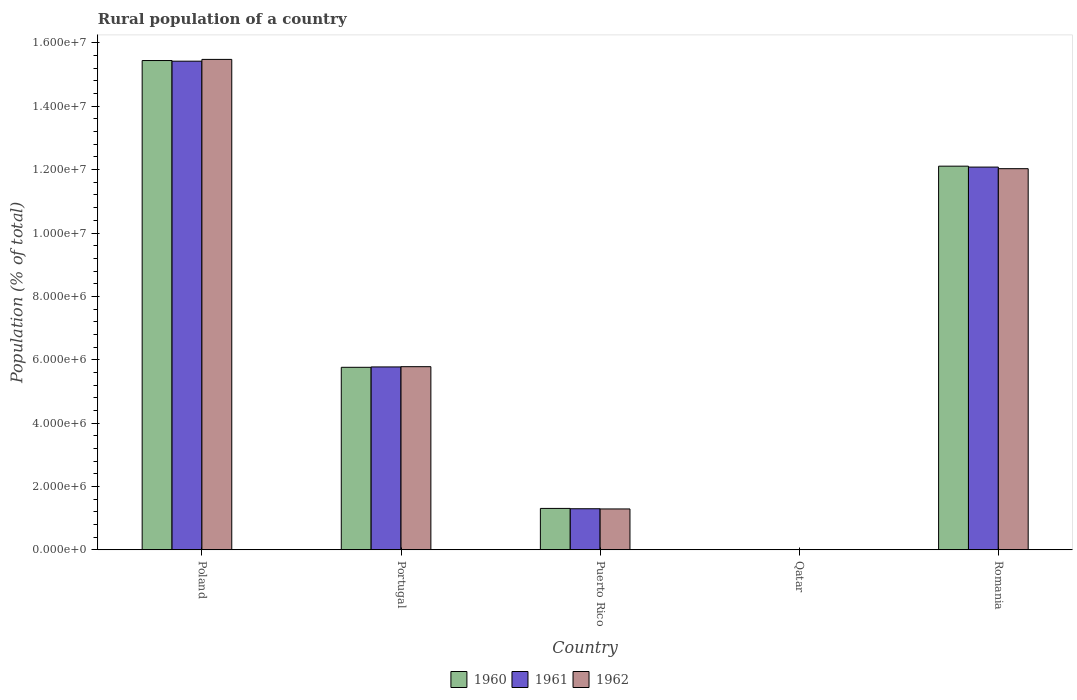How many different coloured bars are there?
Your answer should be very brief. 3. How many groups of bars are there?
Give a very brief answer. 5. Are the number of bars on each tick of the X-axis equal?
Provide a short and direct response. Yes. How many bars are there on the 1st tick from the left?
Ensure brevity in your answer.  3. What is the rural population in 1962 in Portugal?
Your answer should be compact. 5.78e+06. Across all countries, what is the maximum rural population in 1960?
Your answer should be very brief. 1.54e+07. Across all countries, what is the minimum rural population in 1961?
Offer a very short reply. 7347. In which country was the rural population in 1961 maximum?
Offer a very short reply. Poland. In which country was the rural population in 1961 minimum?
Keep it short and to the point. Qatar. What is the total rural population in 1961 in the graph?
Make the answer very short. 3.46e+07. What is the difference between the rural population in 1961 in Poland and that in Portugal?
Offer a very short reply. 9.65e+06. What is the difference between the rural population in 1961 in Qatar and the rural population in 1962 in Puerto Rico?
Offer a very short reply. -1.28e+06. What is the average rural population in 1960 per country?
Provide a succinct answer. 6.93e+06. What is the difference between the rural population of/in 1962 and rural population of/in 1960 in Puerto Rico?
Your response must be concise. -1.69e+04. In how many countries, is the rural population in 1962 greater than 13600000 %?
Offer a very short reply. 1. What is the ratio of the rural population in 1961 in Poland to that in Portugal?
Give a very brief answer. 2.67. What is the difference between the highest and the second highest rural population in 1961?
Offer a very short reply. 9.65e+06. What is the difference between the highest and the lowest rural population in 1961?
Offer a terse response. 1.54e+07. Is the sum of the rural population in 1962 in Portugal and Romania greater than the maximum rural population in 1960 across all countries?
Your response must be concise. Yes. Is it the case that in every country, the sum of the rural population in 1962 and rural population in 1960 is greater than the rural population in 1961?
Ensure brevity in your answer.  Yes. Are all the bars in the graph horizontal?
Provide a succinct answer. No. What is the difference between two consecutive major ticks on the Y-axis?
Offer a very short reply. 2.00e+06. Are the values on the major ticks of Y-axis written in scientific E-notation?
Provide a succinct answer. Yes. Does the graph contain grids?
Provide a short and direct response. No. How many legend labels are there?
Keep it short and to the point. 3. What is the title of the graph?
Your answer should be very brief. Rural population of a country. Does "1960" appear as one of the legend labels in the graph?
Your answer should be very brief. Yes. What is the label or title of the Y-axis?
Offer a terse response. Population (% of total). What is the Population (% of total) in 1960 in Poland?
Your response must be concise. 1.54e+07. What is the Population (% of total) of 1961 in Poland?
Keep it short and to the point. 1.54e+07. What is the Population (% of total) in 1962 in Poland?
Ensure brevity in your answer.  1.55e+07. What is the Population (% of total) of 1960 in Portugal?
Your response must be concise. 5.76e+06. What is the Population (% of total) in 1961 in Portugal?
Provide a succinct answer. 5.77e+06. What is the Population (% of total) in 1962 in Portugal?
Ensure brevity in your answer.  5.78e+06. What is the Population (% of total) in 1960 in Puerto Rico?
Your answer should be very brief. 1.31e+06. What is the Population (% of total) in 1961 in Puerto Rico?
Offer a terse response. 1.30e+06. What is the Population (% of total) in 1962 in Puerto Rico?
Make the answer very short. 1.29e+06. What is the Population (% of total) of 1960 in Qatar?
Give a very brief answer. 6966. What is the Population (% of total) in 1961 in Qatar?
Your answer should be compact. 7347. What is the Population (% of total) in 1962 in Qatar?
Your response must be concise. 7809. What is the Population (% of total) of 1960 in Romania?
Your response must be concise. 1.21e+07. What is the Population (% of total) in 1961 in Romania?
Offer a very short reply. 1.21e+07. What is the Population (% of total) of 1962 in Romania?
Offer a terse response. 1.20e+07. Across all countries, what is the maximum Population (% of total) of 1960?
Offer a terse response. 1.54e+07. Across all countries, what is the maximum Population (% of total) in 1961?
Your response must be concise. 1.54e+07. Across all countries, what is the maximum Population (% of total) in 1962?
Your answer should be compact. 1.55e+07. Across all countries, what is the minimum Population (% of total) of 1960?
Provide a short and direct response. 6966. Across all countries, what is the minimum Population (% of total) in 1961?
Offer a very short reply. 7347. Across all countries, what is the minimum Population (% of total) in 1962?
Offer a very short reply. 7809. What is the total Population (% of total) of 1960 in the graph?
Your answer should be very brief. 3.46e+07. What is the total Population (% of total) of 1961 in the graph?
Give a very brief answer. 3.46e+07. What is the total Population (% of total) of 1962 in the graph?
Give a very brief answer. 3.46e+07. What is the difference between the Population (% of total) of 1960 in Poland and that in Portugal?
Make the answer very short. 9.68e+06. What is the difference between the Population (% of total) of 1961 in Poland and that in Portugal?
Ensure brevity in your answer.  9.65e+06. What is the difference between the Population (% of total) in 1962 in Poland and that in Portugal?
Your answer should be compact. 9.70e+06. What is the difference between the Population (% of total) of 1960 in Poland and that in Puerto Rico?
Offer a very short reply. 1.41e+07. What is the difference between the Population (% of total) of 1961 in Poland and that in Puerto Rico?
Offer a very short reply. 1.41e+07. What is the difference between the Population (% of total) in 1962 in Poland and that in Puerto Rico?
Keep it short and to the point. 1.42e+07. What is the difference between the Population (% of total) of 1960 in Poland and that in Qatar?
Provide a short and direct response. 1.54e+07. What is the difference between the Population (% of total) of 1961 in Poland and that in Qatar?
Your answer should be compact. 1.54e+07. What is the difference between the Population (% of total) in 1962 in Poland and that in Qatar?
Give a very brief answer. 1.55e+07. What is the difference between the Population (% of total) in 1960 in Poland and that in Romania?
Ensure brevity in your answer.  3.33e+06. What is the difference between the Population (% of total) of 1961 in Poland and that in Romania?
Keep it short and to the point. 3.34e+06. What is the difference between the Population (% of total) of 1962 in Poland and that in Romania?
Your answer should be compact. 3.45e+06. What is the difference between the Population (% of total) in 1960 in Portugal and that in Puerto Rico?
Your response must be concise. 4.45e+06. What is the difference between the Population (% of total) of 1961 in Portugal and that in Puerto Rico?
Offer a terse response. 4.48e+06. What is the difference between the Population (% of total) of 1962 in Portugal and that in Puerto Rico?
Provide a short and direct response. 4.49e+06. What is the difference between the Population (% of total) in 1960 in Portugal and that in Qatar?
Your answer should be compact. 5.75e+06. What is the difference between the Population (% of total) of 1961 in Portugal and that in Qatar?
Offer a very short reply. 5.77e+06. What is the difference between the Population (% of total) of 1962 in Portugal and that in Qatar?
Ensure brevity in your answer.  5.77e+06. What is the difference between the Population (% of total) in 1960 in Portugal and that in Romania?
Ensure brevity in your answer.  -6.35e+06. What is the difference between the Population (% of total) in 1961 in Portugal and that in Romania?
Keep it short and to the point. -6.31e+06. What is the difference between the Population (% of total) in 1962 in Portugal and that in Romania?
Your answer should be compact. -6.25e+06. What is the difference between the Population (% of total) of 1960 in Puerto Rico and that in Qatar?
Your response must be concise. 1.30e+06. What is the difference between the Population (% of total) of 1961 in Puerto Rico and that in Qatar?
Your answer should be very brief. 1.29e+06. What is the difference between the Population (% of total) in 1962 in Puerto Rico and that in Qatar?
Make the answer very short. 1.28e+06. What is the difference between the Population (% of total) in 1960 in Puerto Rico and that in Romania?
Your answer should be compact. -1.08e+07. What is the difference between the Population (% of total) in 1961 in Puerto Rico and that in Romania?
Keep it short and to the point. -1.08e+07. What is the difference between the Population (% of total) of 1962 in Puerto Rico and that in Romania?
Offer a terse response. -1.07e+07. What is the difference between the Population (% of total) in 1960 in Qatar and that in Romania?
Your answer should be compact. -1.21e+07. What is the difference between the Population (% of total) of 1961 in Qatar and that in Romania?
Your answer should be compact. -1.21e+07. What is the difference between the Population (% of total) of 1962 in Qatar and that in Romania?
Offer a terse response. -1.20e+07. What is the difference between the Population (% of total) in 1960 in Poland and the Population (% of total) in 1961 in Portugal?
Keep it short and to the point. 9.67e+06. What is the difference between the Population (% of total) of 1960 in Poland and the Population (% of total) of 1962 in Portugal?
Your answer should be compact. 9.66e+06. What is the difference between the Population (% of total) of 1961 in Poland and the Population (% of total) of 1962 in Portugal?
Give a very brief answer. 9.64e+06. What is the difference between the Population (% of total) in 1960 in Poland and the Population (% of total) in 1961 in Puerto Rico?
Keep it short and to the point. 1.41e+07. What is the difference between the Population (% of total) of 1960 in Poland and the Population (% of total) of 1962 in Puerto Rico?
Give a very brief answer. 1.42e+07. What is the difference between the Population (% of total) in 1961 in Poland and the Population (% of total) in 1962 in Puerto Rico?
Your answer should be very brief. 1.41e+07. What is the difference between the Population (% of total) in 1960 in Poland and the Population (% of total) in 1961 in Qatar?
Make the answer very short. 1.54e+07. What is the difference between the Population (% of total) in 1960 in Poland and the Population (% of total) in 1962 in Qatar?
Your response must be concise. 1.54e+07. What is the difference between the Population (% of total) in 1961 in Poland and the Population (% of total) in 1962 in Qatar?
Your response must be concise. 1.54e+07. What is the difference between the Population (% of total) of 1960 in Poland and the Population (% of total) of 1961 in Romania?
Your answer should be very brief. 3.36e+06. What is the difference between the Population (% of total) of 1960 in Poland and the Population (% of total) of 1962 in Romania?
Keep it short and to the point. 3.41e+06. What is the difference between the Population (% of total) of 1961 in Poland and the Population (% of total) of 1962 in Romania?
Make the answer very short. 3.39e+06. What is the difference between the Population (% of total) of 1960 in Portugal and the Population (% of total) of 1961 in Puerto Rico?
Keep it short and to the point. 4.46e+06. What is the difference between the Population (% of total) in 1960 in Portugal and the Population (% of total) in 1962 in Puerto Rico?
Provide a succinct answer. 4.47e+06. What is the difference between the Population (% of total) of 1961 in Portugal and the Population (% of total) of 1962 in Puerto Rico?
Provide a short and direct response. 4.48e+06. What is the difference between the Population (% of total) of 1960 in Portugal and the Population (% of total) of 1961 in Qatar?
Give a very brief answer. 5.75e+06. What is the difference between the Population (% of total) in 1960 in Portugal and the Population (% of total) in 1962 in Qatar?
Your answer should be compact. 5.75e+06. What is the difference between the Population (% of total) of 1961 in Portugal and the Population (% of total) of 1962 in Qatar?
Your answer should be compact. 5.77e+06. What is the difference between the Population (% of total) in 1960 in Portugal and the Population (% of total) in 1961 in Romania?
Your answer should be very brief. -6.32e+06. What is the difference between the Population (% of total) of 1960 in Portugal and the Population (% of total) of 1962 in Romania?
Your response must be concise. -6.27e+06. What is the difference between the Population (% of total) in 1961 in Portugal and the Population (% of total) in 1962 in Romania?
Your response must be concise. -6.26e+06. What is the difference between the Population (% of total) of 1960 in Puerto Rico and the Population (% of total) of 1961 in Qatar?
Ensure brevity in your answer.  1.30e+06. What is the difference between the Population (% of total) in 1960 in Puerto Rico and the Population (% of total) in 1962 in Qatar?
Keep it short and to the point. 1.30e+06. What is the difference between the Population (% of total) in 1961 in Puerto Rico and the Population (% of total) in 1962 in Qatar?
Your response must be concise. 1.29e+06. What is the difference between the Population (% of total) of 1960 in Puerto Rico and the Population (% of total) of 1961 in Romania?
Provide a short and direct response. -1.08e+07. What is the difference between the Population (% of total) of 1960 in Puerto Rico and the Population (% of total) of 1962 in Romania?
Provide a succinct answer. -1.07e+07. What is the difference between the Population (% of total) of 1961 in Puerto Rico and the Population (% of total) of 1962 in Romania?
Your response must be concise. -1.07e+07. What is the difference between the Population (% of total) of 1960 in Qatar and the Population (% of total) of 1961 in Romania?
Your response must be concise. -1.21e+07. What is the difference between the Population (% of total) of 1960 in Qatar and the Population (% of total) of 1962 in Romania?
Give a very brief answer. -1.20e+07. What is the difference between the Population (% of total) of 1961 in Qatar and the Population (% of total) of 1962 in Romania?
Keep it short and to the point. -1.20e+07. What is the average Population (% of total) in 1960 per country?
Your answer should be very brief. 6.93e+06. What is the average Population (% of total) in 1961 per country?
Your answer should be very brief. 6.92e+06. What is the average Population (% of total) of 1962 per country?
Keep it short and to the point. 6.92e+06. What is the difference between the Population (% of total) in 1960 and Population (% of total) in 1961 in Poland?
Give a very brief answer. 2.01e+04. What is the difference between the Population (% of total) in 1960 and Population (% of total) in 1962 in Poland?
Ensure brevity in your answer.  -3.63e+04. What is the difference between the Population (% of total) in 1961 and Population (% of total) in 1962 in Poland?
Provide a short and direct response. -5.64e+04. What is the difference between the Population (% of total) of 1960 and Population (% of total) of 1961 in Portugal?
Your answer should be very brief. -1.18e+04. What is the difference between the Population (% of total) of 1960 and Population (% of total) of 1962 in Portugal?
Offer a very short reply. -1.97e+04. What is the difference between the Population (% of total) in 1961 and Population (% of total) in 1962 in Portugal?
Offer a terse response. -7815. What is the difference between the Population (% of total) of 1960 and Population (% of total) of 1961 in Puerto Rico?
Keep it short and to the point. 1.01e+04. What is the difference between the Population (% of total) of 1960 and Population (% of total) of 1962 in Puerto Rico?
Provide a succinct answer. 1.69e+04. What is the difference between the Population (% of total) in 1961 and Population (% of total) in 1962 in Puerto Rico?
Your response must be concise. 6800. What is the difference between the Population (% of total) of 1960 and Population (% of total) of 1961 in Qatar?
Give a very brief answer. -381. What is the difference between the Population (% of total) of 1960 and Population (% of total) of 1962 in Qatar?
Ensure brevity in your answer.  -843. What is the difference between the Population (% of total) in 1961 and Population (% of total) in 1962 in Qatar?
Offer a terse response. -462. What is the difference between the Population (% of total) of 1960 and Population (% of total) of 1961 in Romania?
Keep it short and to the point. 2.95e+04. What is the difference between the Population (% of total) in 1960 and Population (% of total) in 1962 in Romania?
Keep it short and to the point. 7.98e+04. What is the difference between the Population (% of total) in 1961 and Population (% of total) in 1962 in Romania?
Your answer should be compact. 5.03e+04. What is the ratio of the Population (% of total) of 1960 in Poland to that in Portugal?
Provide a short and direct response. 2.68. What is the ratio of the Population (% of total) of 1961 in Poland to that in Portugal?
Make the answer very short. 2.67. What is the ratio of the Population (% of total) of 1962 in Poland to that in Portugal?
Your answer should be very brief. 2.68. What is the ratio of the Population (% of total) in 1960 in Poland to that in Puerto Rico?
Your answer should be compact. 11.81. What is the ratio of the Population (% of total) in 1961 in Poland to that in Puerto Rico?
Ensure brevity in your answer.  11.89. What is the ratio of the Population (% of total) of 1962 in Poland to that in Puerto Rico?
Provide a succinct answer. 11.99. What is the ratio of the Population (% of total) of 1960 in Poland to that in Qatar?
Provide a short and direct response. 2216.98. What is the ratio of the Population (% of total) in 1961 in Poland to that in Qatar?
Offer a terse response. 2099.27. What is the ratio of the Population (% of total) of 1962 in Poland to that in Qatar?
Offer a terse response. 1982.3. What is the ratio of the Population (% of total) of 1960 in Poland to that in Romania?
Make the answer very short. 1.28. What is the ratio of the Population (% of total) of 1961 in Poland to that in Romania?
Offer a very short reply. 1.28. What is the ratio of the Population (% of total) in 1962 in Poland to that in Romania?
Your answer should be very brief. 1.29. What is the ratio of the Population (% of total) in 1960 in Portugal to that in Puerto Rico?
Offer a very short reply. 4.41. What is the ratio of the Population (% of total) of 1961 in Portugal to that in Puerto Rico?
Offer a terse response. 4.45. What is the ratio of the Population (% of total) in 1962 in Portugal to that in Puerto Rico?
Keep it short and to the point. 4.48. What is the ratio of the Population (% of total) in 1960 in Portugal to that in Qatar?
Make the answer very short. 827.09. What is the ratio of the Population (% of total) of 1961 in Portugal to that in Qatar?
Give a very brief answer. 785.81. What is the ratio of the Population (% of total) in 1962 in Portugal to that in Qatar?
Offer a very short reply. 740.32. What is the ratio of the Population (% of total) in 1960 in Portugal to that in Romania?
Make the answer very short. 0.48. What is the ratio of the Population (% of total) in 1961 in Portugal to that in Romania?
Offer a very short reply. 0.48. What is the ratio of the Population (% of total) in 1962 in Portugal to that in Romania?
Ensure brevity in your answer.  0.48. What is the ratio of the Population (% of total) in 1960 in Puerto Rico to that in Qatar?
Make the answer very short. 187.71. What is the ratio of the Population (% of total) of 1961 in Puerto Rico to that in Qatar?
Offer a terse response. 176.6. What is the ratio of the Population (% of total) in 1962 in Puerto Rico to that in Qatar?
Provide a short and direct response. 165.28. What is the ratio of the Population (% of total) in 1960 in Puerto Rico to that in Romania?
Ensure brevity in your answer.  0.11. What is the ratio of the Population (% of total) of 1961 in Puerto Rico to that in Romania?
Your response must be concise. 0.11. What is the ratio of the Population (% of total) in 1962 in Puerto Rico to that in Romania?
Offer a very short reply. 0.11. What is the ratio of the Population (% of total) in 1960 in Qatar to that in Romania?
Ensure brevity in your answer.  0. What is the ratio of the Population (% of total) of 1961 in Qatar to that in Romania?
Give a very brief answer. 0. What is the ratio of the Population (% of total) of 1962 in Qatar to that in Romania?
Ensure brevity in your answer.  0. What is the difference between the highest and the second highest Population (% of total) of 1960?
Your response must be concise. 3.33e+06. What is the difference between the highest and the second highest Population (% of total) of 1961?
Your answer should be compact. 3.34e+06. What is the difference between the highest and the second highest Population (% of total) of 1962?
Your response must be concise. 3.45e+06. What is the difference between the highest and the lowest Population (% of total) of 1960?
Ensure brevity in your answer.  1.54e+07. What is the difference between the highest and the lowest Population (% of total) in 1961?
Make the answer very short. 1.54e+07. What is the difference between the highest and the lowest Population (% of total) of 1962?
Provide a short and direct response. 1.55e+07. 